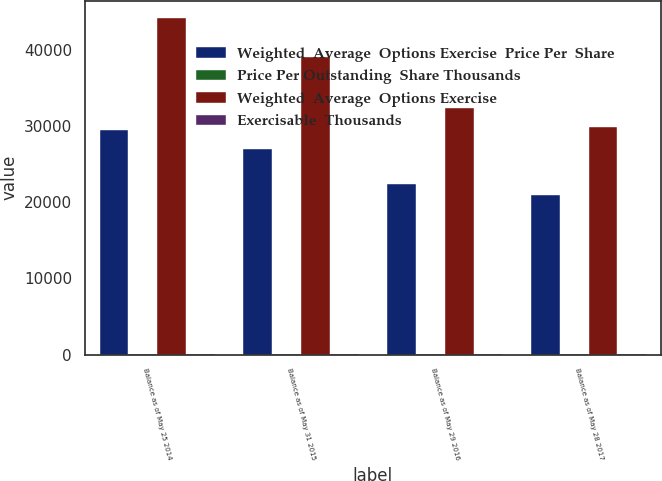<chart> <loc_0><loc_0><loc_500><loc_500><stacked_bar_chart><ecel><fcel>Balance as of May 25 2014<fcel>Balance as of May 31 2015<fcel>Balance as of May 29 2016<fcel>Balance as of May 28 2017<nl><fcel>Weighted  Average  Options Exercise  Price Per  Share<fcel>29452.8<fcel>26991.5<fcel>22385.1<fcel>20899.2<nl><fcel>Price Per Outstanding  Share Thousands<fcel>28.37<fcel>30.44<fcel>32.38<fcel>33.83<nl><fcel>Weighted  Average  Options Exercise<fcel>44169<fcel>39077.2<fcel>32401.6<fcel>29834.4<nl><fcel>Exercisable  Thousands<fcel>32.1<fcel>34.35<fcel>37.09<fcel>40.47<nl></chart> 